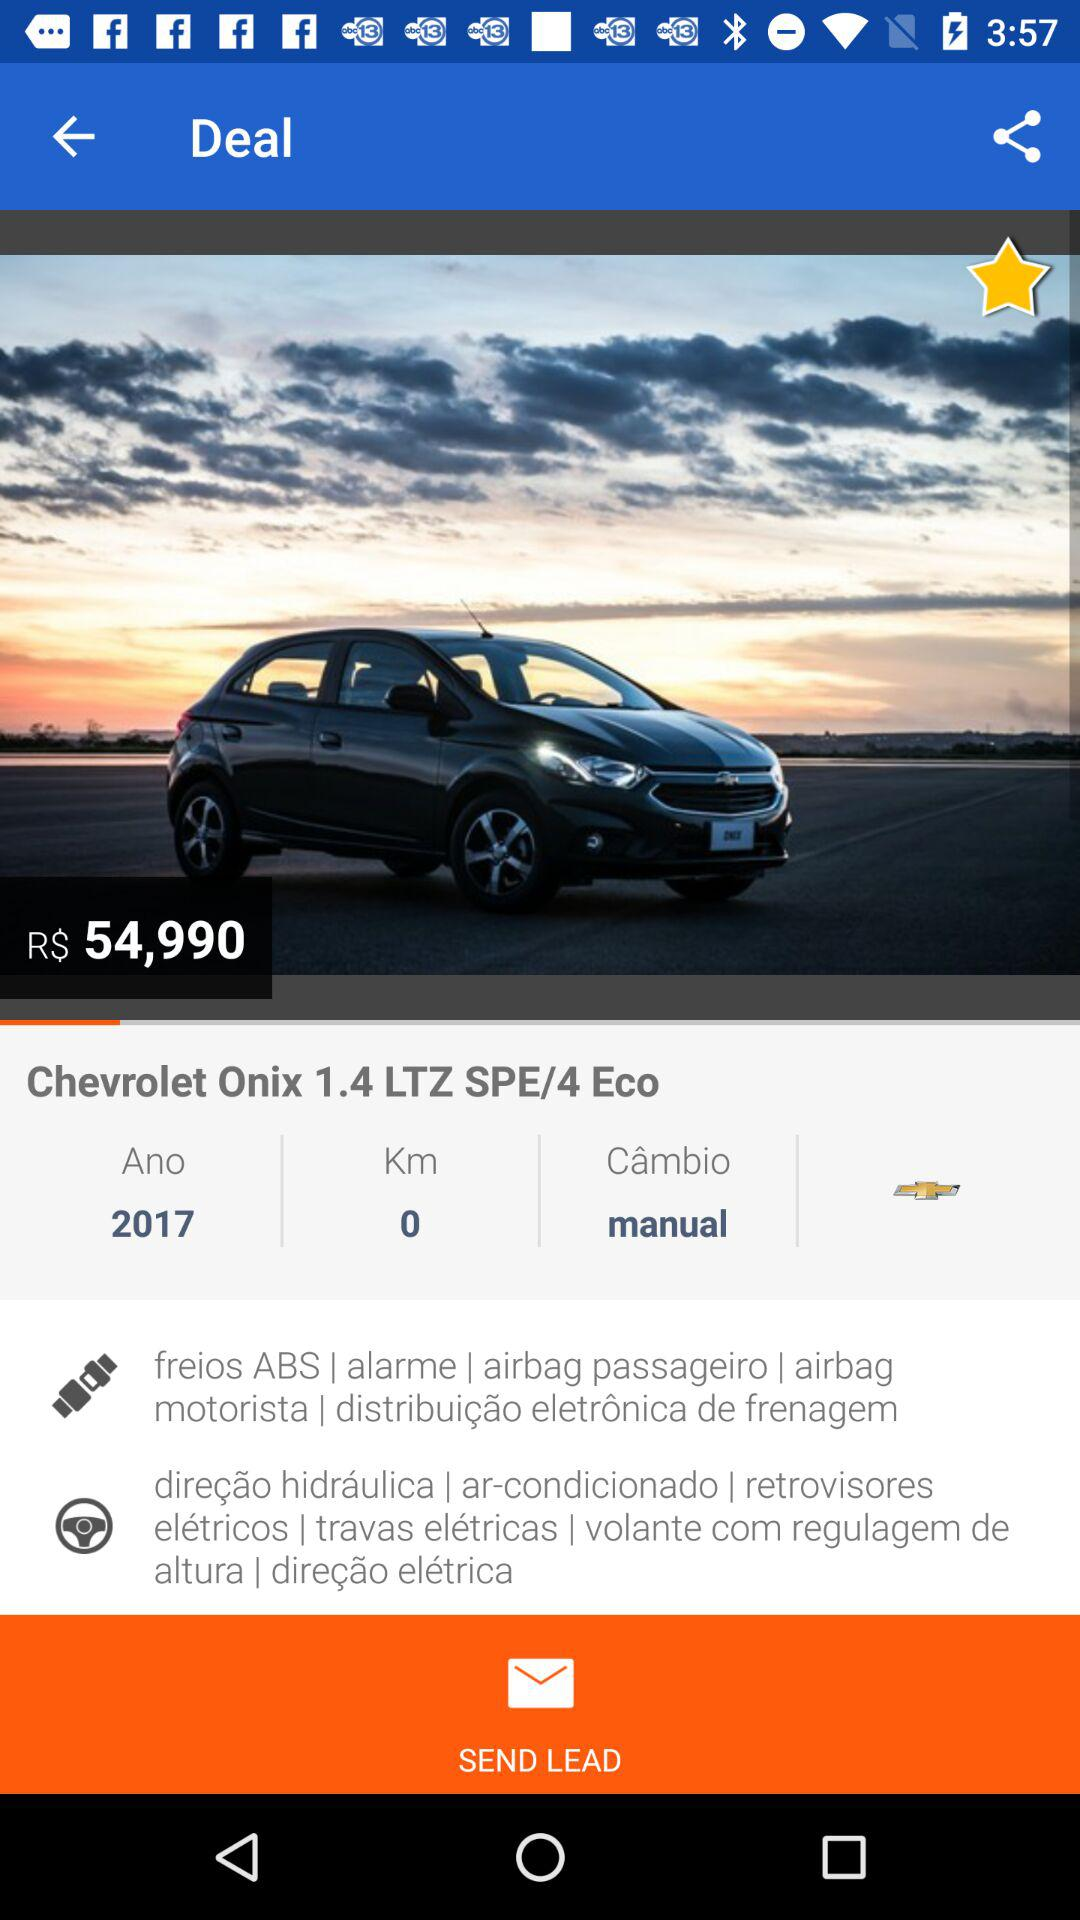How many kilometers does the car have?
Answer the question using a single word or phrase. 0 